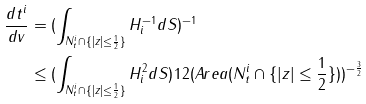<formula> <loc_0><loc_0><loc_500><loc_500>\frac { d t ^ { i } } { d v } & = ( \int _ { N ^ { i } _ { t } \cap \{ | z | \leq \frac { 1 } { 2 } \} } H ^ { - 1 } _ { i } d S ) ^ { - 1 } \\ & \leq ( \int _ { N ^ { i } _ { t } \cap \{ | z | \leq \frac { 1 } { 2 } \} } H ^ { 2 } _ { i } d S ) ^ { } { 1 } 2 ( A r e a ( N ^ { i } _ { t } \cap \{ | z | \leq \frac { 1 } { 2 } \} ) ) ^ { - \frac { 3 } { 2 } }</formula> 